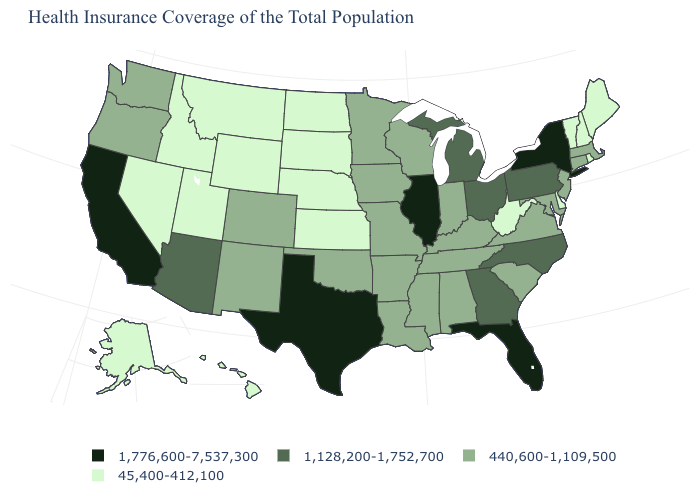Among the states that border Maryland , which have the lowest value?
Write a very short answer. Delaware, West Virginia. What is the value of Texas?
Write a very short answer. 1,776,600-7,537,300. Which states have the lowest value in the MidWest?
Be succinct. Kansas, Nebraska, North Dakota, South Dakota. Name the states that have a value in the range 440,600-1,109,500?
Give a very brief answer. Alabama, Arkansas, Colorado, Connecticut, Indiana, Iowa, Kentucky, Louisiana, Maryland, Massachusetts, Minnesota, Mississippi, Missouri, New Jersey, New Mexico, Oklahoma, Oregon, South Carolina, Tennessee, Virginia, Washington, Wisconsin. What is the value of Wisconsin?
Concise answer only. 440,600-1,109,500. What is the lowest value in the USA?
Write a very short answer. 45,400-412,100. What is the value of Pennsylvania?
Keep it brief. 1,128,200-1,752,700. Is the legend a continuous bar?
Be succinct. No. What is the lowest value in the MidWest?
Quick response, please. 45,400-412,100. Name the states that have a value in the range 45,400-412,100?
Answer briefly. Alaska, Delaware, Hawaii, Idaho, Kansas, Maine, Montana, Nebraska, Nevada, New Hampshire, North Dakota, Rhode Island, South Dakota, Utah, Vermont, West Virginia, Wyoming. Among the states that border New Jersey , does New York have the highest value?
Short answer required. Yes. What is the value of Wisconsin?
Answer briefly. 440,600-1,109,500. Among the states that border Kansas , which have the lowest value?
Quick response, please. Nebraska. Does California have the highest value in the USA?
Answer briefly. Yes. Which states have the highest value in the USA?
Keep it brief. California, Florida, Illinois, New York, Texas. 